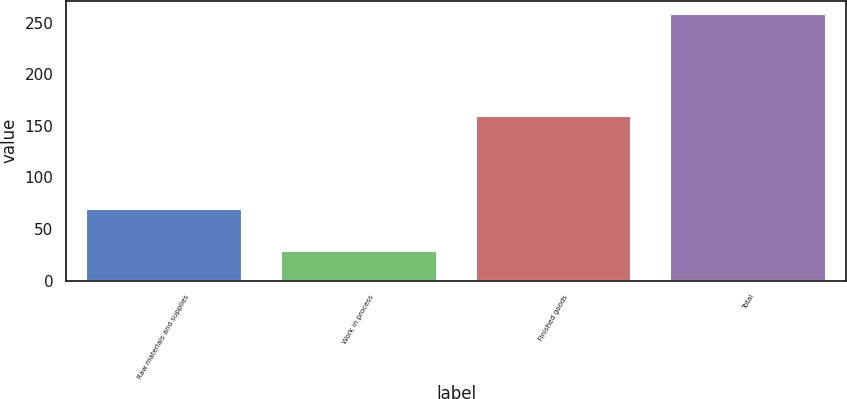Convert chart. <chart><loc_0><loc_0><loc_500><loc_500><bar_chart><fcel>Raw materials and supplies<fcel>Work in process<fcel>Finished goods<fcel>Total<nl><fcel>69.8<fcel>28.8<fcel>159.6<fcel>258.2<nl></chart> 